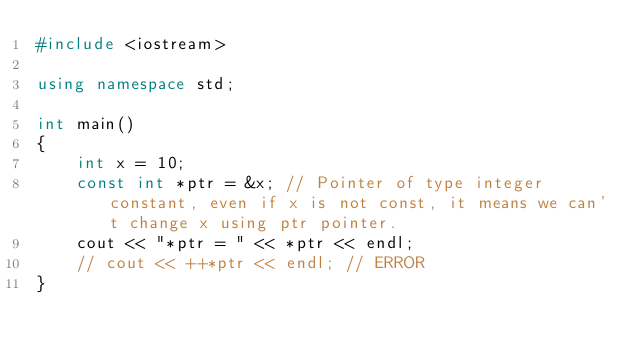Convert code to text. <code><loc_0><loc_0><loc_500><loc_500><_C++_>#include <iostream>

using namespace std;

int main()
{
    int x = 10;
    const int *ptr = &x; // Pointer of type integer constant, even if x is not const, it means we can't change x using ptr pointer.
    cout << "*ptr = " << *ptr << endl;
    // cout << ++*ptr << endl; // ERROR
}
</code> 